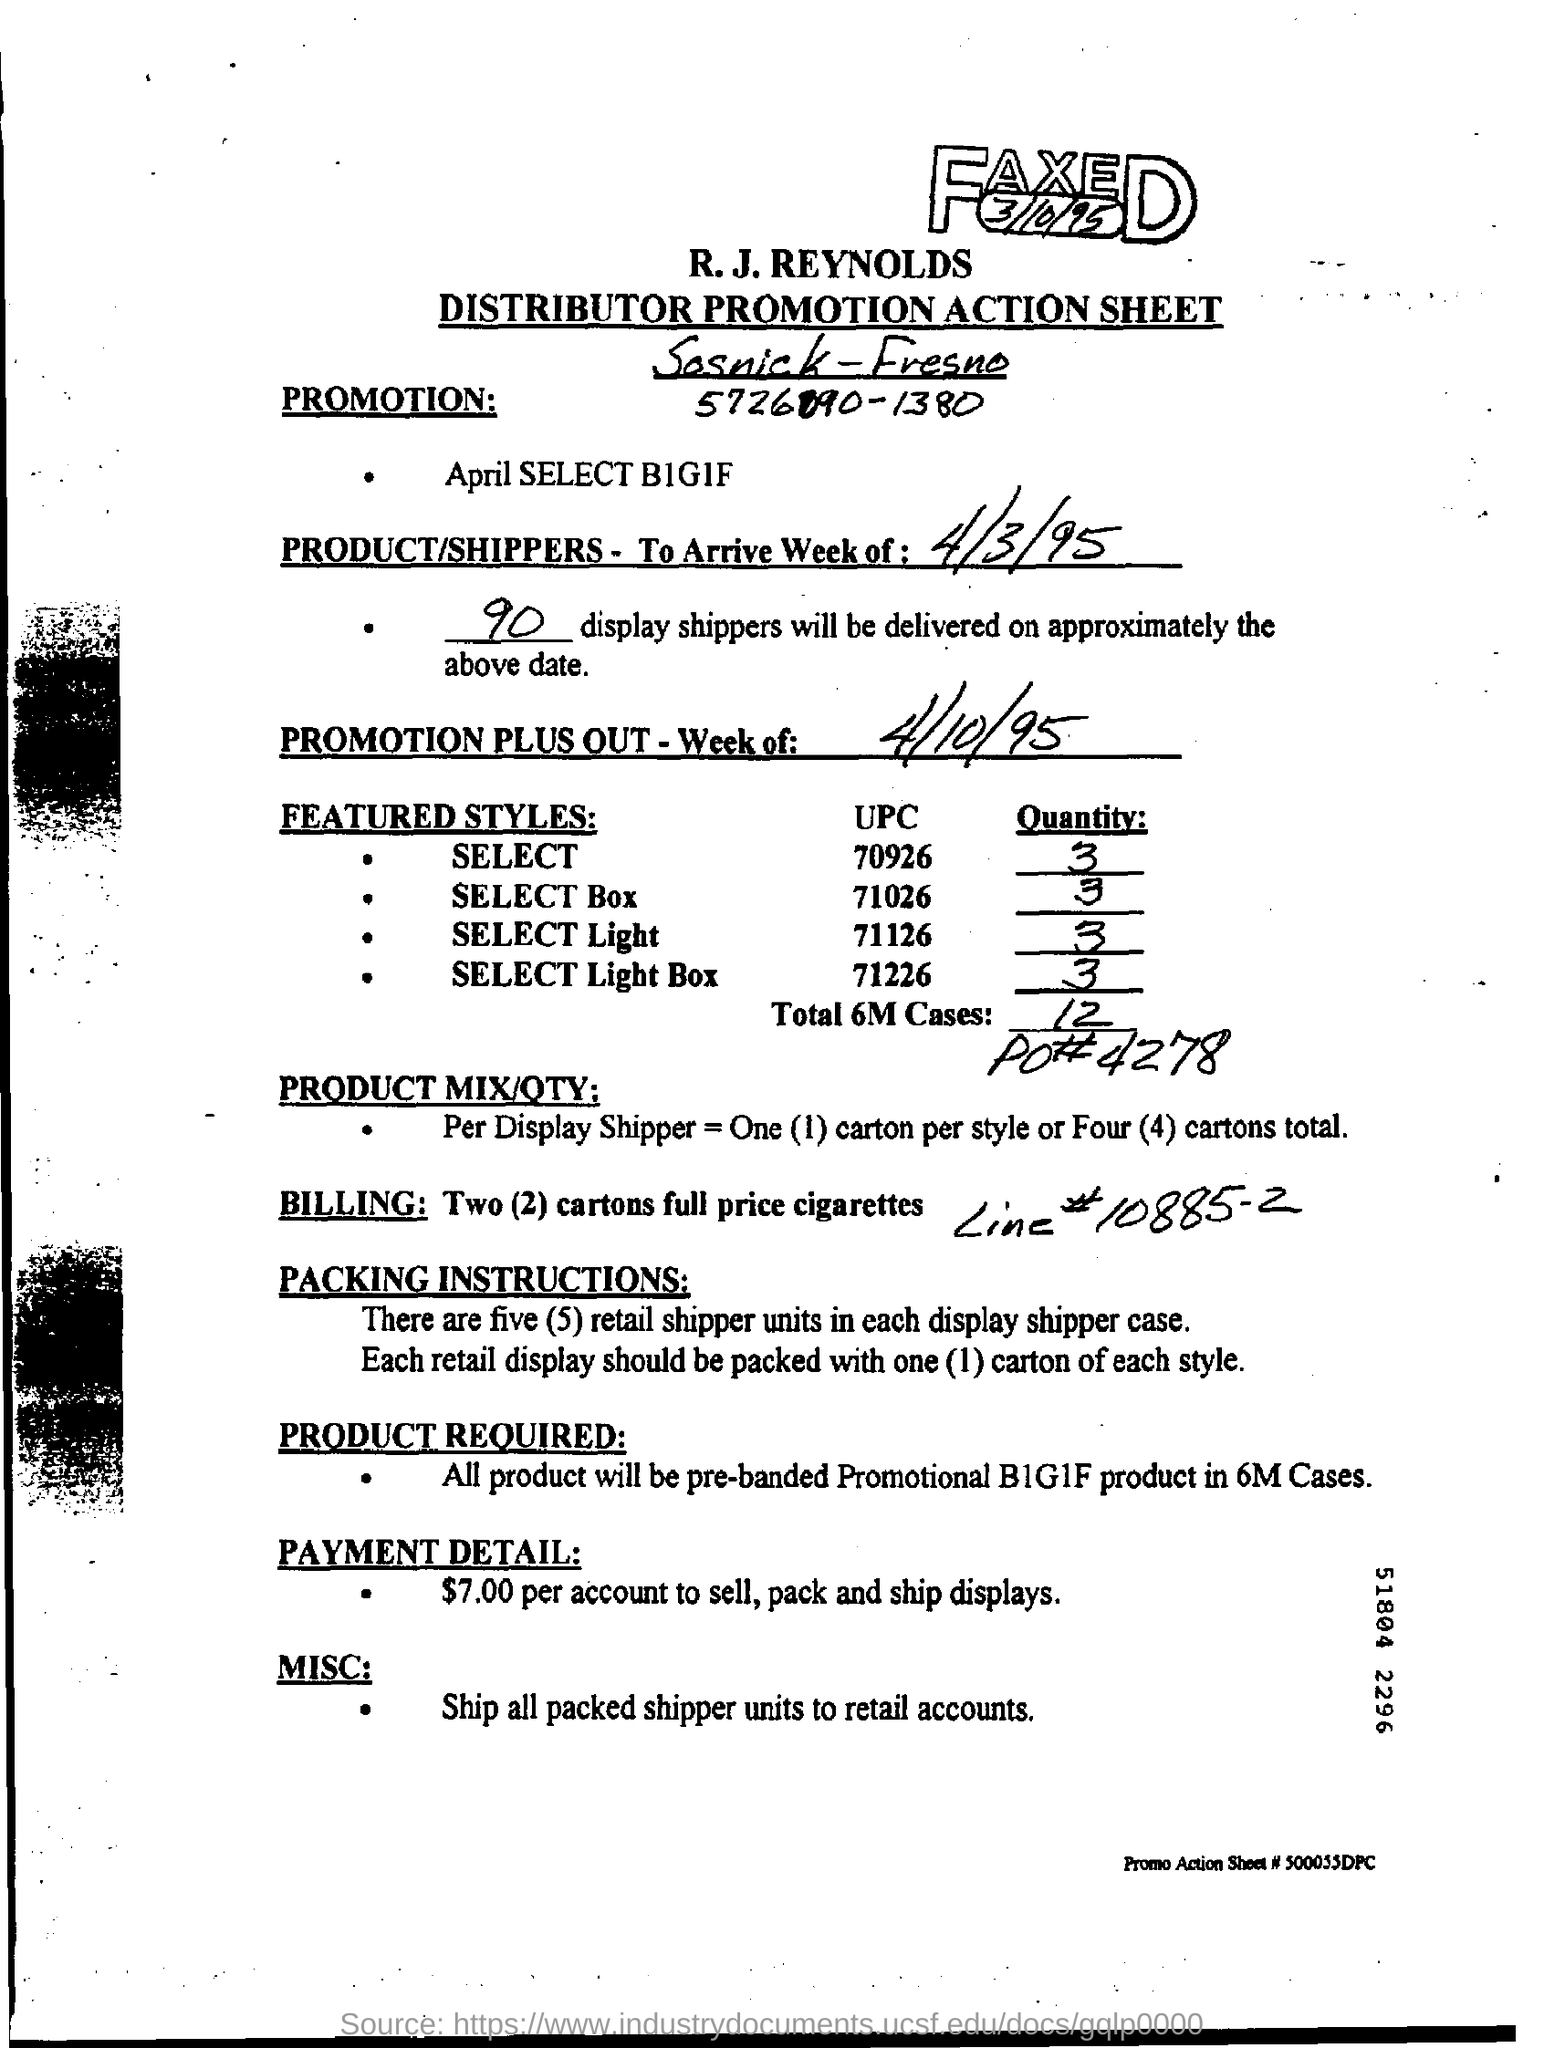Specify some key components in this picture. There are five retail shipper units in each display shipper case. All packed shipper units are shipped to retail accounts. 